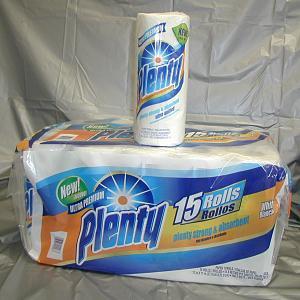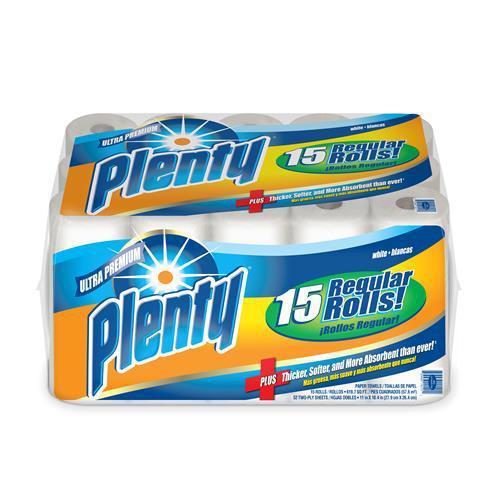The first image is the image on the left, the second image is the image on the right. For the images displayed, is the sentence "There are exactly 31 rolls of paper towels." factually correct? Answer yes or no. Yes. The first image is the image on the left, the second image is the image on the right. Examine the images to the left and right. Is the description "There are two packages of paper towels and one single paper towel roll." accurate? Answer yes or no. Yes. 